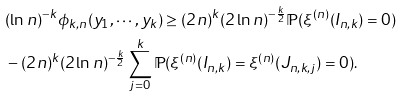<formula> <loc_0><loc_0><loc_500><loc_500>& ( \ln n ) ^ { - k } \phi _ { k , n } ( y _ { 1 } , \cdots , y _ { k } ) \geq ( 2 n ) ^ { k } ( 2 \ln n ) ^ { - \frac { k } { 2 } } \mathbb { P } ( \xi ^ { ( n ) } ( I _ { n , k } ) = 0 ) \\ & - ( 2 n ) ^ { k } ( 2 \ln n ) ^ { - \frac { k } { 2 } } \sum _ { j = 0 } ^ { k } \mathbb { P } ( \xi ^ { ( n ) } ( I _ { n , k } ) = \xi ^ { ( n ) } ( J _ { n , k , j } ) = 0 ) .</formula> 